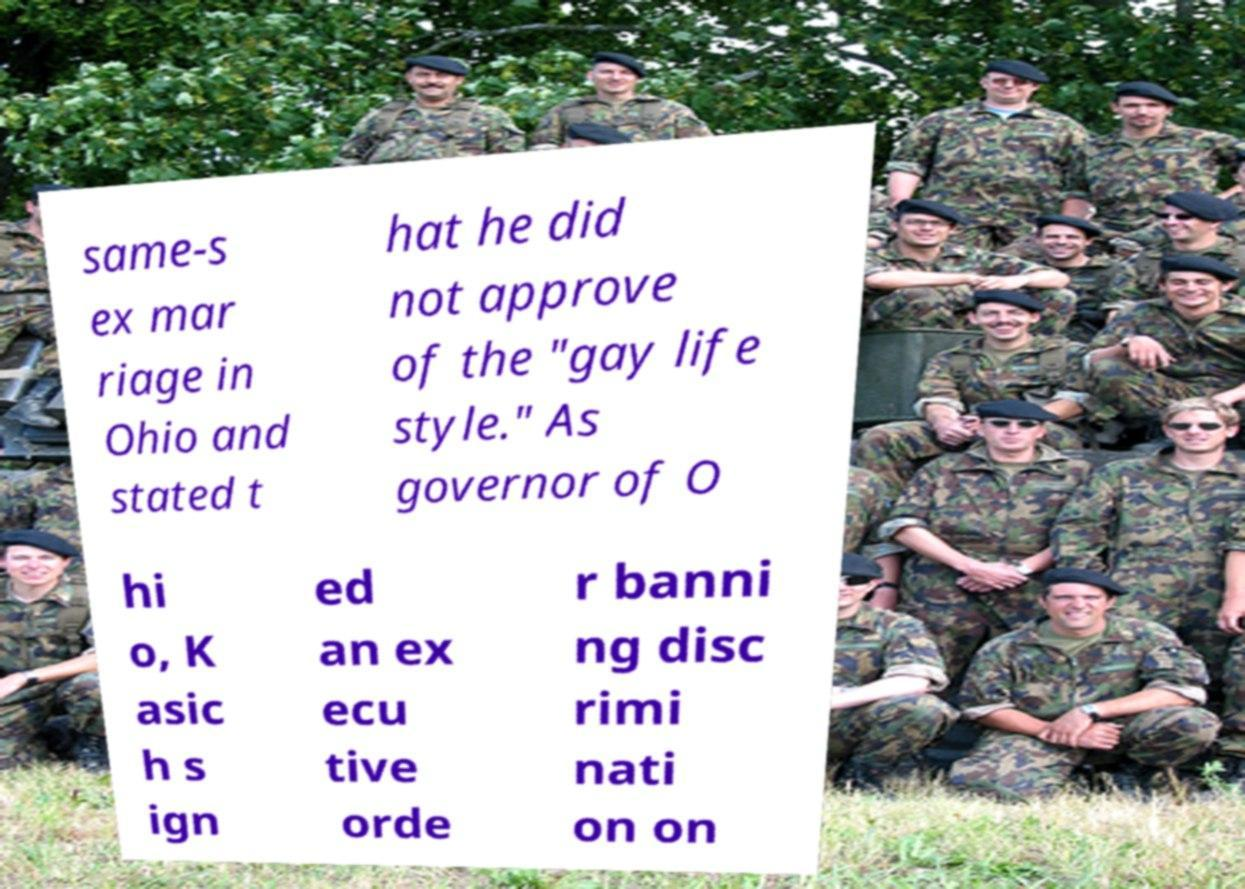Please identify and transcribe the text found in this image. same-s ex mar riage in Ohio and stated t hat he did not approve of the "gay life style." As governor of O hi o, K asic h s ign ed an ex ecu tive orde r banni ng disc rimi nati on on 